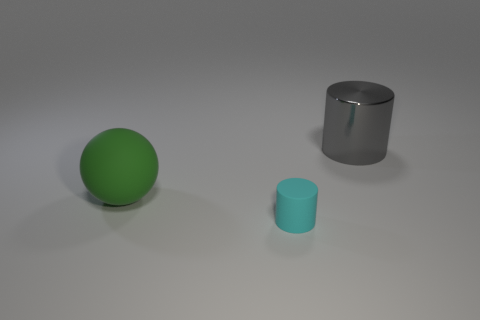There is a thing right of the tiny rubber thing; is it the same shape as the object that is in front of the big green rubber thing?
Keep it short and to the point. Yes. There is a object that is both behind the cyan object and right of the green object; what is its color?
Provide a succinct answer. Gray. Does the cylinder in front of the large shiny cylinder have the same size as the object behind the ball?
Your answer should be very brief. No. What number of large things are either matte spheres or purple metallic balls?
Offer a very short reply. 1. Is the material of the object that is in front of the matte sphere the same as the ball?
Make the answer very short. Yes. What color is the matte object that is in front of the large green rubber object?
Offer a terse response. Cyan. Are there any cylinders of the same size as the green object?
Provide a succinct answer. Yes. What is the material of the object that is the same size as the gray cylinder?
Make the answer very short. Rubber. Do the cyan matte cylinder and the cylinder behind the big green object have the same size?
Offer a terse response. No. There is a big object that is behind the green object; what material is it?
Offer a terse response. Metal. 